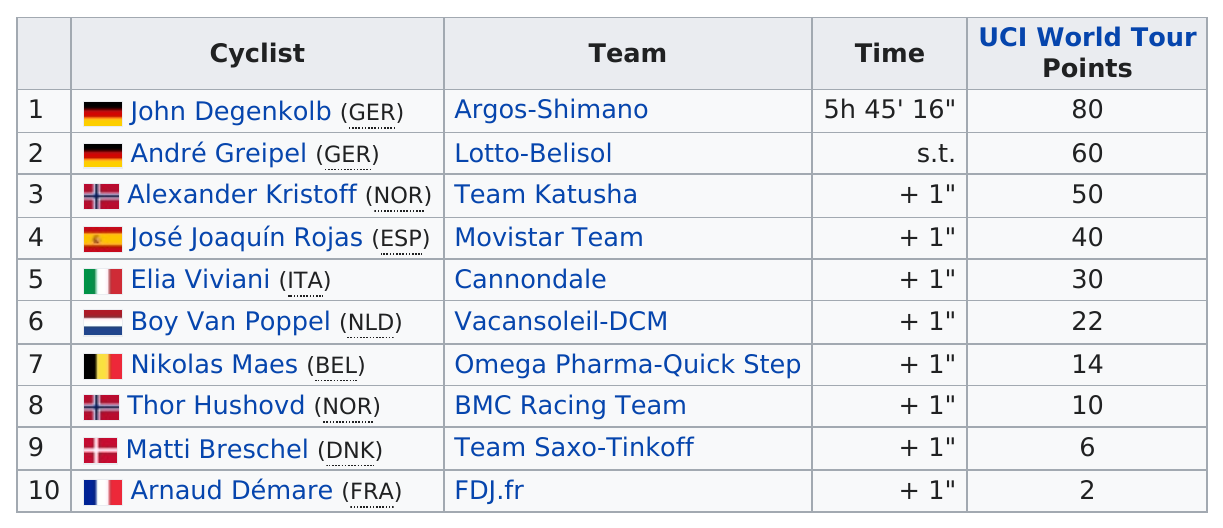Point out several critical features in this image. John Degenkolb completed the world tour in a time of 5 hours and 45 minutes and 16 seconds. Boy Van Poppel, a cyclist from the Netherlands, obtained a total of 22 UCI World Tour points. The player from Italy has earned a total of 30 UCI World Tour points. The difference in UCI points between Nikolas Maes and John Degenkolb is 66. José Joaquín Rojas, a cyclist from the Movistar Team, was originally from either the Movistar Team or Team Katusha. He was from the Movistar Team. 